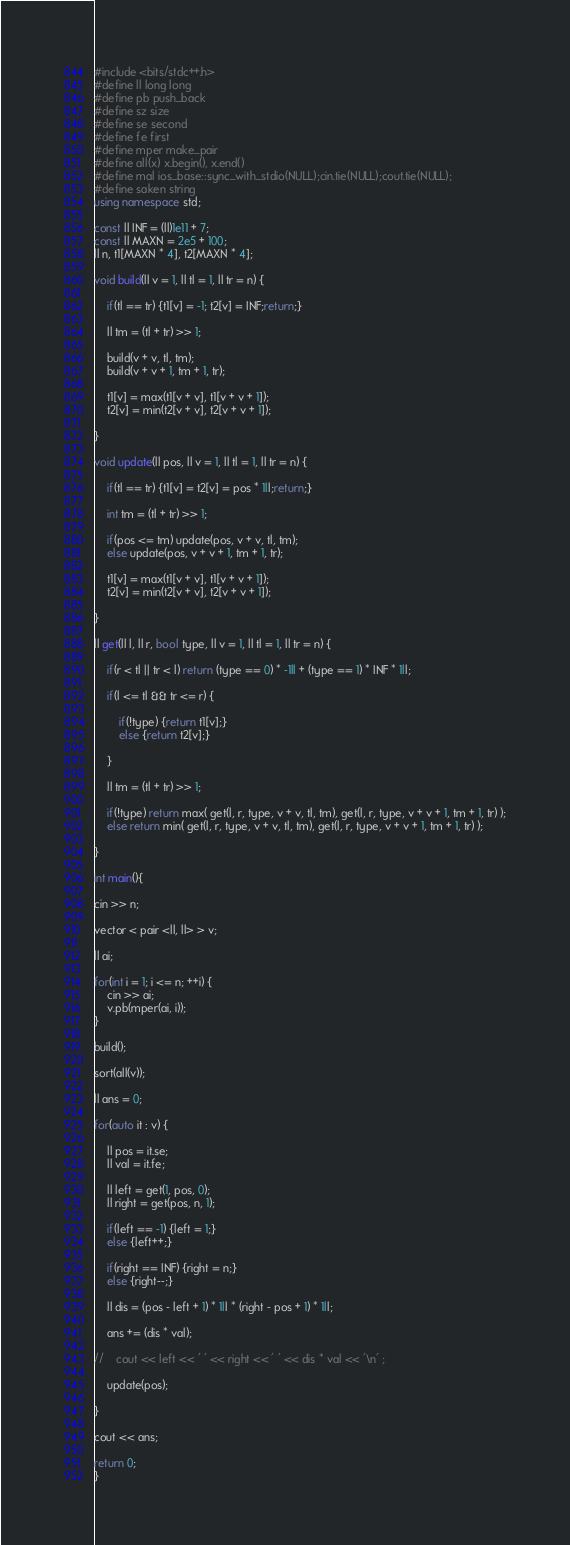Convert code to text. <code><loc_0><loc_0><loc_500><loc_500><_C++_>#include <bits/stdc++.h>
#define ll long long
#define pb push_back
#define sz size
#define se second
#define fe first
#define mper make_pair
#define all(x) x.begin(), x.end()
#define mal ios_base::sync_with_stdio(NULL);cin.tie(NULL);cout.tie(NULL);
#define saken string
using namespace std;

const ll INF = (ll)1e11 + 7;
const ll MAXN = 2e5 + 100;
ll n, t1[MAXN * 4], t2[MAXN * 4];

void build(ll v = 1, ll tl = 1, ll tr = n) {

    if(tl == tr) {t1[v] = -1; t2[v] = INF;return;}

    ll tm = (tl + tr) >> 1;

    build(v + v, tl, tm);
    build(v + v + 1, tm + 1, tr);

    t1[v] = max(t1[v + v], t1[v + v + 1]);
    t2[v] = min(t2[v + v], t2[v + v + 1]);

}

void update(ll pos, ll v = 1, ll tl = 1, ll tr = n) {

    if(tl == tr) {t1[v] = t2[v] = pos * 1ll;return;}

    int tm = (tl + tr) >> 1;

    if(pos <= tm) update(pos, v + v, tl, tm);
    else update(pos, v + v + 1, tm + 1, tr);

    t1[v] = max(t1[v + v], t1[v + v + 1]);
    t2[v] = min(t2[v + v], t2[v + v + 1]);

}

ll get(ll l, ll r, bool type, ll v = 1, ll tl = 1, ll tr = n) {

    if(r < tl || tr < l) return (type == 0) * -1ll + (type == 1) * INF * 1ll;

    if(l <= tl && tr <= r) {

        if(!type) {return t1[v];}
        else {return t2[v];}

    }

    ll tm = (tl + tr) >> 1;

    if(!type) return max( get(l, r, type, v + v, tl, tm), get(l, r, type, v + v + 1, tm + 1, tr) );
    else return min( get(l, r, type, v + v, tl, tm), get(l, r, type, v + v + 1, tm + 1, tr) );

}

int main(){

cin >> n;

vector < pair <ll, ll> > v;

ll ai;

for(int i = 1; i <= n; ++i) {
    cin >> ai;
    v.pb(mper(ai, i));
}

build();

sort(all(v));

ll ans = 0;

for(auto it : v) {

    ll pos = it.se;
    ll val = it.fe;

    ll left = get(1, pos, 0);
    ll right = get(pos, n, 1);

    if(left == -1) {left = 1;}
    else {left++;}

    if(right == INF) {right = n;}
    else {right--;}

    ll dis = (pos - left + 1) * 1ll * (right - pos + 1) * 1ll;

    ans += (dis * val);

//    cout << left << ' ' << right << ' ' << dis * val << '\n' ;

    update(pos);

}

cout << ans;

return 0;
}

</code> 